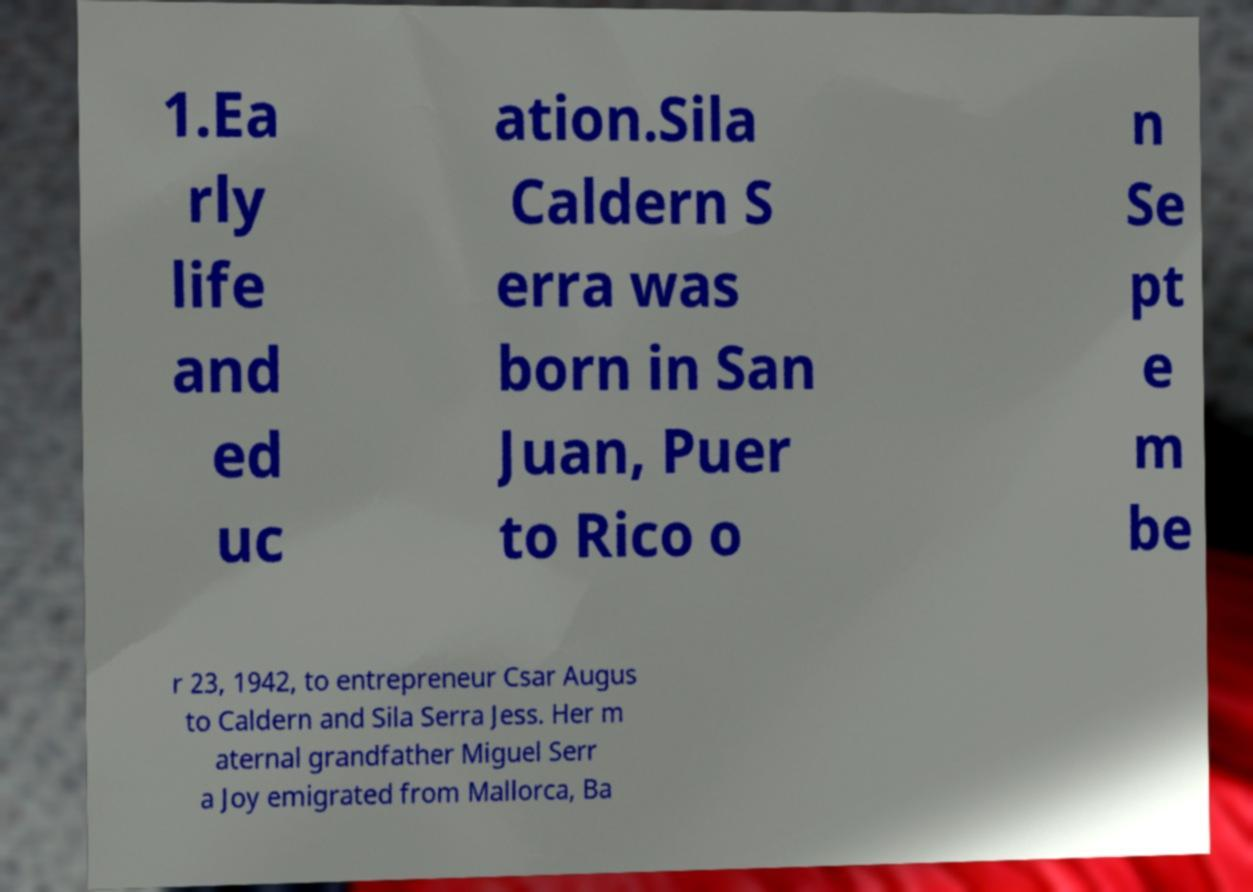There's text embedded in this image that I need extracted. Can you transcribe it verbatim? 1.Ea rly life and ed uc ation.Sila Caldern S erra was born in San Juan, Puer to Rico o n Se pt e m be r 23, 1942, to entrepreneur Csar Augus to Caldern and Sila Serra Jess. Her m aternal grandfather Miguel Serr a Joy emigrated from Mallorca, Ba 